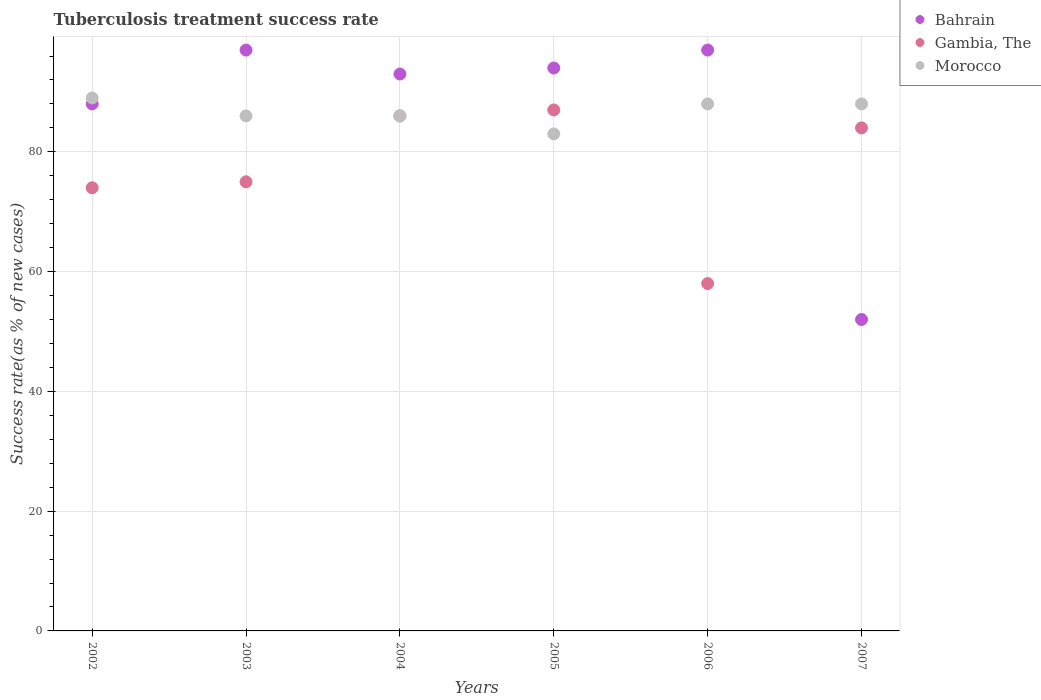Is the number of dotlines equal to the number of legend labels?
Provide a succinct answer. Yes. What is the tuberculosis treatment success rate in Morocco in 2003?
Provide a succinct answer. 86. Across all years, what is the minimum tuberculosis treatment success rate in Morocco?
Give a very brief answer. 83. In which year was the tuberculosis treatment success rate in Bahrain maximum?
Offer a terse response. 2003. In which year was the tuberculosis treatment success rate in Morocco minimum?
Your response must be concise. 2005. What is the total tuberculosis treatment success rate in Bahrain in the graph?
Provide a succinct answer. 521. What is the difference between the tuberculosis treatment success rate in Bahrain in 2005 and that in 2006?
Your answer should be compact. -3. What is the difference between the tuberculosis treatment success rate in Gambia, The in 2006 and the tuberculosis treatment success rate in Bahrain in 2004?
Your response must be concise. -35. What is the average tuberculosis treatment success rate in Gambia, The per year?
Your answer should be compact. 77.33. In the year 2006, what is the difference between the tuberculosis treatment success rate in Gambia, The and tuberculosis treatment success rate in Morocco?
Make the answer very short. -30. What is the ratio of the tuberculosis treatment success rate in Gambia, The in 2003 to that in 2005?
Ensure brevity in your answer.  0.86. Is the tuberculosis treatment success rate in Morocco in 2003 less than that in 2006?
Keep it short and to the point. Yes. What is the difference between the highest and the second highest tuberculosis treatment success rate in Bahrain?
Provide a succinct answer. 0. Is the tuberculosis treatment success rate in Gambia, The strictly greater than the tuberculosis treatment success rate in Bahrain over the years?
Offer a terse response. No. How many years are there in the graph?
Your answer should be very brief. 6. What is the difference between two consecutive major ticks on the Y-axis?
Provide a succinct answer. 20. Does the graph contain any zero values?
Provide a short and direct response. No. Where does the legend appear in the graph?
Give a very brief answer. Top right. How many legend labels are there?
Offer a terse response. 3. How are the legend labels stacked?
Offer a very short reply. Vertical. What is the title of the graph?
Keep it short and to the point. Tuberculosis treatment success rate. What is the label or title of the X-axis?
Ensure brevity in your answer.  Years. What is the label or title of the Y-axis?
Your answer should be compact. Success rate(as % of new cases). What is the Success rate(as % of new cases) in Morocco in 2002?
Ensure brevity in your answer.  89. What is the Success rate(as % of new cases) in Bahrain in 2003?
Your response must be concise. 97. What is the Success rate(as % of new cases) of Gambia, The in 2003?
Make the answer very short. 75. What is the Success rate(as % of new cases) in Morocco in 2003?
Make the answer very short. 86. What is the Success rate(as % of new cases) in Bahrain in 2004?
Provide a short and direct response. 93. What is the Success rate(as % of new cases) of Morocco in 2004?
Give a very brief answer. 86. What is the Success rate(as % of new cases) in Bahrain in 2005?
Keep it short and to the point. 94. What is the Success rate(as % of new cases) of Gambia, The in 2005?
Make the answer very short. 87. What is the Success rate(as % of new cases) in Bahrain in 2006?
Ensure brevity in your answer.  97. What is the Success rate(as % of new cases) in Gambia, The in 2006?
Provide a short and direct response. 58. What is the Success rate(as % of new cases) in Bahrain in 2007?
Your response must be concise. 52. What is the Success rate(as % of new cases) of Gambia, The in 2007?
Make the answer very short. 84. Across all years, what is the maximum Success rate(as % of new cases) in Bahrain?
Your answer should be very brief. 97. Across all years, what is the maximum Success rate(as % of new cases) in Gambia, The?
Provide a short and direct response. 87. Across all years, what is the maximum Success rate(as % of new cases) in Morocco?
Offer a terse response. 89. Across all years, what is the minimum Success rate(as % of new cases) in Bahrain?
Keep it short and to the point. 52. What is the total Success rate(as % of new cases) in Bahrain in the graph?
Your response must be concise. 521. What is the total Success rate(as % of new cases) in Gambia, The in the graph?
Keep it short and to the point. 464. What is the total Success rate(as % of new cases) in Morocco in the graph?
Keep it short and to the point. 520. What is the difference between the Success rate(as % of new cases) of Bahrain in 2002 and that in 2003?
Keep it short and to the point. -9. What is the difference between the Success rate(as % of new cases) of Gambia, The in 2002 and that in 2003?
Offer a very short reply. -1. What is the difference between the Success rate(as % of new cases) in Bahrain in 2002 and that in 2004?
Ensure brevity in your answer.  -5. What is the difference between the Success rate(as % of new cases) of Gambia, The in 2002 and that in 2005?
Offer a very short reply. -13. What is the difference between the Success rate(as % of new cases) of Bahrain in 2002 and that in 2006?
Offer a very short reply. -9. What is the difference between the Success rate(as % of new cases) in Morocco in 2002 and that in 2006?
Your answer should be very brief. 1. What is the difference between the Success rate(as % of new cases) of Gambia, The in 2002 and that in 2007?
Your answer should be very brief. -10. What is the difference between the Success rate(as % of new cases) of Gambia, The in 2003 and that in 2004?
Ensure brevity in your answer.  -11. What is the difference between the Success rate(as % of new cases) in Bahrain in 2003 and that in 2005?
Provide a short and direct response. 3. What is the difference between the Success rate(as % of new cases) of Morocco in 2003 and that in 2005?
Your answer should be compact. 3. What is the difference between the Success rate(as % of new cases) of Gambia, The in 2003 and that in 2006?
Provide a succinct answer. 17. What is the difference between the Success rate(as % of new cases) in Bahrain in 2003 and that in 2007?
Keep it short and to the point. 45. What is the difference between the Success rate(as % of new cases) in Gambia, The in 2003 and that in 2007?
Offer a very short reply. -9. What is the difference between the Success rate(as % of new cases) in Morocco in 2003 and that in 2007?
Offer a terse response. -2. What is the difference between the Success rate(as % of new cases) in Bahrain in 2004 and that in 2005?
Offer a terse response. -1. What is the difference between the Success rate(as % of new cases) in Morocco in 2004 and that in 2005?
Make the answer very short. 3. What is the difference between the Success rate(as % of new cases) of Gambia, The in 2004 and that in 2006?
Ensure brevity in your answer.  28. What is the difference between the Success rate(as % of new cases) in Gambia, The in 2004 and that in 2007?
Provide a short and direct response. 2. What is the difference between the Success rate(as % of new cases) of Bahrain in 2005 and that in 2006?
Make the answer very short. -3. What is the difference between the Success rate(as % of new cases) in Gambia, The in 2005 and that in 2006?
Provide a short and direct response. 29. What is the difference between the Success rate(as % of new cases) of Morocco in 2005 and that in 2007?
Give a very brief answer. -5. What is the difference between the Success rate(as % of new cases) in Bahrain in 2006 and that in 2007?
Give a very brief answer. 45. What is the difference between the Success rate(as % of new cases) in Gambia, The in 2006 and that in 2007?
Your response must be concise. -26. What is the difference between the Success rate(as % of new cases) in Bahrain in 2002 and the Success rate(as % of new cases) in Gambia, The in 2003?
Provide a short and direct response. 13. What is the difference between the Success rate(as % of new cases) in Gambia, The in 2002 and the Success rate(as % of new cases) in Morocco in 2003?
Your response must be concise. -12. What is the difference between the Success rate(as % of new cases) in Bahrain in 2002 and the Success rate(as % of new cases) in Gambia, The in 2004?
Ensure brevity in your answer.  2. What is the difference between the Success rate(as % of new cases) in Bahrain in 2002 and the Success rate(as % of new cases) in Morocco in 2004?
Ensure brevity in your answer.  2. What is the difference between the Success rate(as % of new cases) of Bahrain in 2002 and the Success rate(as % of new cases) of Morocco in 2005?
Provide a short and direct response. 5. What is the difference between the Success rate(as % of new cases) in Bahrain in 2002 and the Success rate(as % of new cases) in Gambia, The in 2006?
Offer a very short reply. 30. What is the difference between the Success rate(as % of new cases) in Bahrain in 2002 and the Success rate(as % of new cases) in Gambia, The in 2007?
Your answer should be very brief. 4. What is the difference between the Success rate(as % of new cases) of Bahrain in 2003 and the Success rate(as % of new cases) of Morocco in 2004?
Provide a succinct answer. 11. What is the difference between the Success rate(as % of new cases) in Gambia, The in 2003 and the Success rate(as % of new cases) in Morocco in 2004?
Your response must be concise. -11. What is the difference between the Success rate(as % of new cases) in Bahrain in 2003 and the Success rate(as % of new cases) in Gambia, The in 2005?
Give a very brief answer. 10. What is the difference between the Success rate(as % of new cases) of Bahrain in 2003 and the Success rate(as % of new cases) of Gambia, The in 2006?
Provide a short and direct response. 39. What is the difference between the Success rate(as % of new cases) in Bahrain in 2003 and the Success rate(as % of new cases) in Morocco in 2006?
Provide a short and direct response. 9. What is the difference between the Success rate(as % of new cases) of Bahrain in 2003 and the Success rate(as % of new cases) of Gambia, The in 2007?
Give a very brief answer. 13. What is the difference between the Success rate(as % of new cases) of Bahrain in 2004 and the Success rate(as % of new cases) of Gambia, The in 2005?
Give a very brief answer. 6. What is the difference between the Success rate(as % of new cases) in Bahrain in 2004 and the Success rate(as % of new cases) in Gambia, The in 2006?
Give a very brief answer. 35. What is the difference between the Success rate(as % of new cases) in Bahrain in 2004 and the Success rate(as % of new cases) in Gambia, The in 2007?
Your answer should be very brief. 9. What is the difference between the Success rate(as % of new cases) in Bahrain in 2004 and the Success rate(as % of new cases) in Morocco in 2007?
Provide a short and direct response. 5. What is the difference between the Success rate(as % of new cases) of Bahrain in 2005 and the Success rate(as % of new cases) of Gambia, The in 2006?
Make the answer very short. 36. What is the difference between the Success rate(as % of new cases) in Gambia, The in 2005 and the Success rate(as % of new cases) in Morocco in 2006?
Provide a succinct answer. -1. What is the difference between the Success rate(as % of new cases) in Bahrain in 2005 and the Success rate(as % of new cases) in Gambia, The in 2007?
Provide a short and direct response. 10. What is the difference between the Success rate(as % of new cases) of Bahrain in 2006 and the Success rate(as % of new cases) of Gambia, The in 2007?
Provide a short and direct response. 13. What is the difference between the Success rate(as % of new cases) of Bahrain in 2006 and the Success rate(as % of new cases) of Morocco in 2007?
Provide a succinct answer. 9. What is the average Success rate(as % of new cases) in Bahrain per year?
Provide a short and direct response. 86.83. What is the average Success rate(as % of new cases) of Gambia, The per year?
Keep it short and to the point. 77.33. What is the average Success rate(as % of new cases) of Morocco per year?
Keep it short and to the point. 86.67. In the year 2002, what is the difference between the Success rate(as % of new cases) of Bahrain and Success rate(as % of new cases) of Gambia, The?
Your answer should be very brief. 14. In the year 2002, what is the difference between the Success rate(as % of new cases) in Gambia, The and Success rate(as % of new cases) in Morocco?
Your answer should be compact. -15. In the year 2003, what is the difference between the Success rate(as % of new cases) in Bahrain and Success rate(as % of new cases) in Morocco?
Your answer should be very brief. 11. In the year 2003, what is the difference between the Success rate(as % of new cases) of Gambia, The and Success rate(as % of new cases) of Morocco?
Ensure brevity in your answer.  -11. In the year 2004, what is the difference between the Success rate(as % of new cases) in Bahrain and Success rate(as % of new cases) in Gambia, The?
Provide a succinct answer. 7. In the year 2004, what is the difference between the Success rate(as % of new cases) in Bahrain and Success rate(as % of new cases) in Morocco?
Your response must be concise. 7. In the year 2004, what is the difference between the Success rate(as % of new cases) of Gambia, The and Success rate(as % of new cases) of Morocco?
Ensure brevity in your answer.  0. In the year 2005, what is the difference between the Success rate(as % of new cases) in Bahrain and Success rate(as % of new cases) in Gambia, The?
Provide a short and direct response. 7. In the year 2005, what is the difference between the Success rate(as % of new cases) in Bahrain and Success rate(as % of new cases) in Morocco?
Your response must be concise. 11. In the year 2007, what is the difference between the Success rate(as % of new cases) of Bahrain and Success rate(as % of new cases) of Gambia, The?
Offer a terse response. -32. In the year 2007, what is the difference between the Success rate(as % of new cases) of Bahrain and Success rate(as % of new cases) of Morocco?
Your answer should be compact. -36. What is the ratio of the Success rate(as % of new cases) in Bahrain in 2002 to that in 2003?
Your response must be concise. 0.91. What is the ratio of the Success rate(as % of new cases) in Gambia, The in 2002 to that in 2003?
Give a very brief answer. 0.99. What is the ratio of the Success rate(as % of new cases) of Morocco in 2002 to that in 2003?
Provide a short and direct response. 1.03. What is the ratio of the Success rate(as % of new cases) of Bahrain in 2002 to that in 2004?
Give a very brief answer. 0.95. What is the ratio of the Success rate(as % of new cases) in Gambia, The in 2002 to that in 2004?
Make the answer very short. 0.86. What is the ratio of the Success rate(as % of new cases) of Morocco in 2002 to that in 2004?
Your response must be concise. 1.03. What is the ratio of the Success rate(as % of new cases) of Bahrain in 2002 to that in 2005?
Make the answer very short. 0.94. What is the ratio of the Success rate(as % of new cases) of Gambia, The in 2002 to that in 2005?
Offer a terse response. 0.85. What is the ratio of the Success rate(as % of new cases) of Morocco in 2002 to that in 2005?
Your answer should be compact. 1.07. What is the ratio of the Success rate(as % of new cases) in Bahrain in 2002 to that in 2006?
Your response must be concise. 0.91. What is the ratio of the Success rate(as % of new cases) in Gambia, The in 2002 to that in 2006?
Offer a very short reply. 1.28. What is the ratio of the Success rate(as % of new cases) in Morocco in 2002 to that in 2006?
Provide a short and direct response. 1.01. What is the ratio of the Success rate(as % of new cases) in Bahrain in 2002 to that in 2007?
Offer a terse response. 1.69. What is the ratio of the Success rate(as % of new cases) of Gambia, The in 2002 to that in 2007?
Provide a succinct answer. 0.88. What is the ratio of the Success rate(as % of new cases) in Morocco in 2002 to that in 2007?
Offer a very short reply. 1.01. What is the ratio of the Success rate(as % of new cases) of Bahrain in 2003 to that in 2004?
Provide a short and direct response. 1.04. What is the ratio of the Success rate(as % of new cases) in Gambia, The in 2003 to that in 2004?
Give a very brief answer. 0.87. What is the ratio of the Success rate(as % of new cases) of Morocco in 2003 to that in 2004?
Provide a short and direct response. 1. What is the ratio of the Success rate(as % of new cases) of Bahrain in 2003 to that in 2005?
Offer a terse response. 1.03. What is the ratio of the Success rate(as % of new cases) of Gambia, The in 2003 to that in 2005?
Provide a succinct answer. 0.86. What is the ratio of the Success rate(as % of new cases) of Morocco in 2003 to that in 2005?
Provide a short and direct response. 1.04. What is the ratio of the Success rate(as % of new cases) of Gambia, The in 2003 to that in 2006?
Offer a very short reply. 1.29. What is the ratio of the Success rate(as % of new cases) of Morocco in 2003 to that in 2006?
Provide a short and direct response. 0.98. What is the ratio of the Success rate(as % of new cases) of Bahrain in 2003 to that in 2007?
Make the answer very short. 1.87. What is the ratio of the Success rate(as % of new cases) of Gambia, The in 2003 to that in 2007?
Provide a succinct answer. 0.89. What is the ratio of the Success rate(as % of new cases) in Morocco in 2003 to that in 2007?
Your response must be concise. 0.98. What is the ratio of the Success rate(as % of new cases) of Morocco in 2004 to that in 2005?
Offer a very short reply. 1.04. What is the ratio of the Success rate(as % of new cases) in Bahrain in 2004 to that in 2006?
Keep it short and to the point. 0.96. What is the ratio of the Success rate(as % of new cases) in Gambia, The in 2004 to that in 2006?
Offer a very short reply. 1.48. What is the ratio of the Success rate(as % of new cases) in Morocco in 2004 to that in 2006?
Your response must be concise. 0.98. What is the ratio of the Success rate(as % of new cases) in Bahrain in 2004 to that in 2007?
Your answer should be very brief. 1.79. What is the ratio of the Success rate(as % of new cases) of Gambia, The in 2004 to that in 2007?
Provide a succinct answer. 1.02. What is the ratio of the Success rate(as % of new cases) in Morocco in 2004 to that in 2007?
Ensure brevity in your answer.  0.98. What is the ratio of the Success rate(as % of new cases) of Bahrain in 2005 to that in 2006?
Your answer should be compact. 0.97. What is the ratio of the Success rate(as % of new cases) of Gambia, The in 2005 to that in 2006?
Keep it short and to the point. 1.5. What is the ratio of the Success rate(as % of new cases) in Morocco in 2005 to that in 2006?
Your answer should be very brief. 0.94. What is the ratio of the Success rate(as % of new cases) in Bahrain in 2005 to that in 2007?
Your answer should be compact. 1.81. What is the ratio of the Success rate(as % of new cases) in Gambia, The in 2005 to that in 2007?
Offer a very short reply. 1.04. What is the ratio of the Success rate(as % of new cases) of Morocco in 2005 to that in 2007?
Keep it short and to the point. 0.94. What is the ratio of the Success rate(as % of new cases) of Bahrain in 2006 to that in 2007?
Make the answer very short. 1.87. What is the ratio of the Success rate(as % of new cases) in Gambia, The in 2006 to that in 2007?
Give a very brief answer. 0.69. What is the difference between the highest and the second highest Success rate(as % of new cases) of Bahrain?
Provide a short and direct response. 0. What is the difference between the highest and the second highest Success rate(as % of new cases) of Gambia, The?
Offer a very short reply. 1. What is the difference between the highest and the second highest Success rate(as % of new cases) of Morocco?
Give a very brief answer. 1. What is the difference between the highest and the lowest Success rate(as % of new cases) of Bahrain?
Your response must be concise. 45. What is the difference between the highest and the lowest Success rate(as % of new cases) in Morocco?
Your answer should be very brief. 6. 